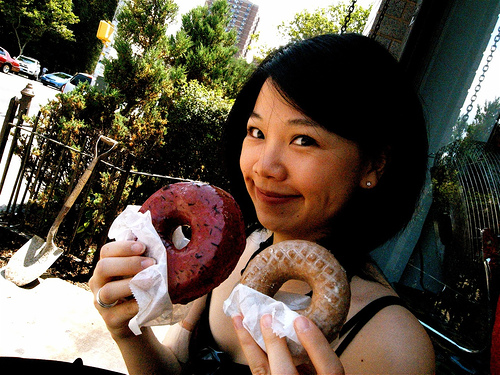How many fingernails are visible? In the image, a total of five fingernails are clearly visible as the person is holding up two donuts with one hand, showcasing the nails on the thumb and the first four fingers. 